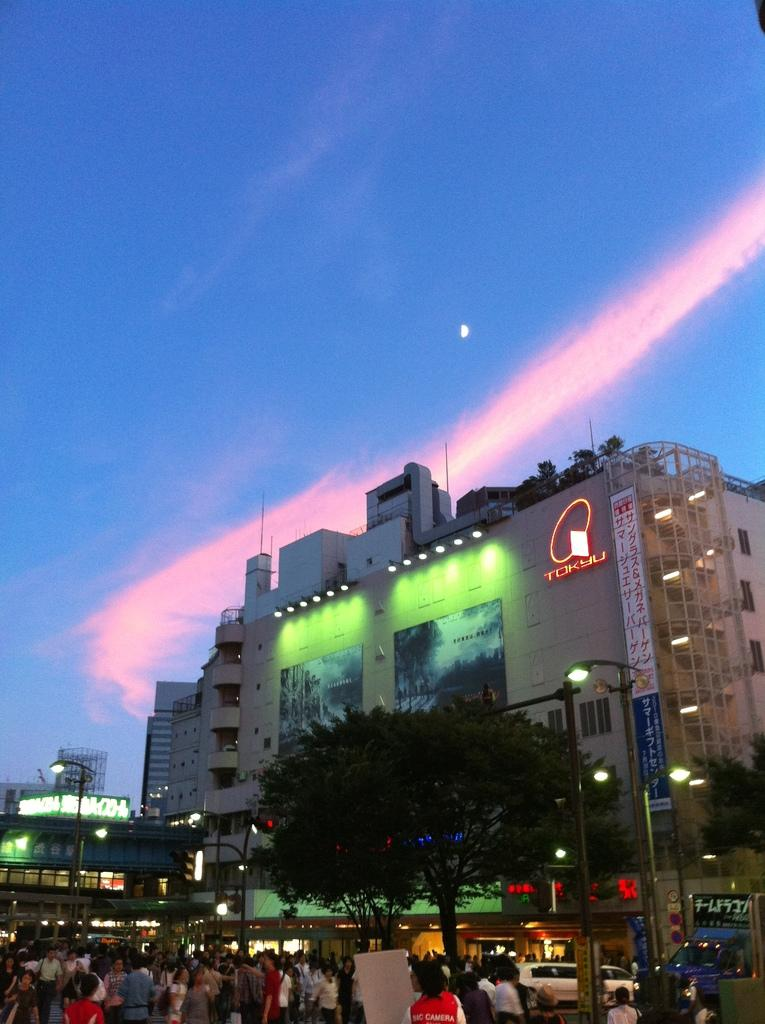What can be seen in the image? There are persons standing in the image. What is visible in the background of the image? There is a tree, buildings, lights, and other objects in the background of the image. Can you describe the setting of the image? The image appears to be set in an urban environment with buildings and lights in the background. What type of cave can be seen in the image? There is no cave present in the image; it features persons standing in an urban environment with buildings and lights in the background. What print can be seen on the persons' clothing in the image? The provided facts do not mention any specific prints on the persons' clothing, so it cannot be determined from the image. 